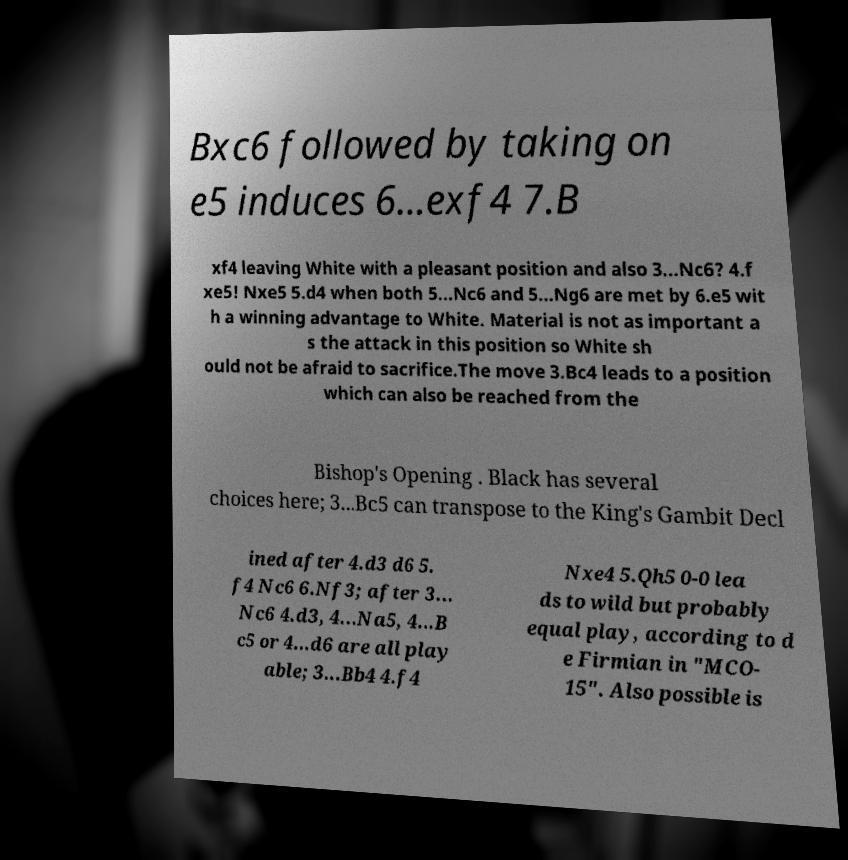Can you accurately transcribe the text from the provided image for me? Bxc6 followed by taking on e5 induces 6...exf4 7.B xf4 leaving White with a pleasant position and also 3...Nc6? 4.f xe5! Nxe5 5.d4 when both 5...Nc6 and 5...Ng6 are met by 6.e5 wit h a winning advantage to White. Material is not as important a s the attack in this position so White sh ould not be afraid to sacrifice.The move 3.Bc4 leads to a position which can also be reached from the Bishop's Opening . Black has several choices here; 3...Bc5 can transpose to the King's Gambit Decl ined after 4.d3 d6 5. f4 Nc6 6.Nf3; after 3... Nc6 4.d3, 4...Na5, 4...B c5 or 4...d6 are all play able; 3...Bb4 4.f4 Nxe4 5.Qh5 0-0 lea ds to wild but probably equal play, according to d e Firmian in "MCO- 15". Also possible is 